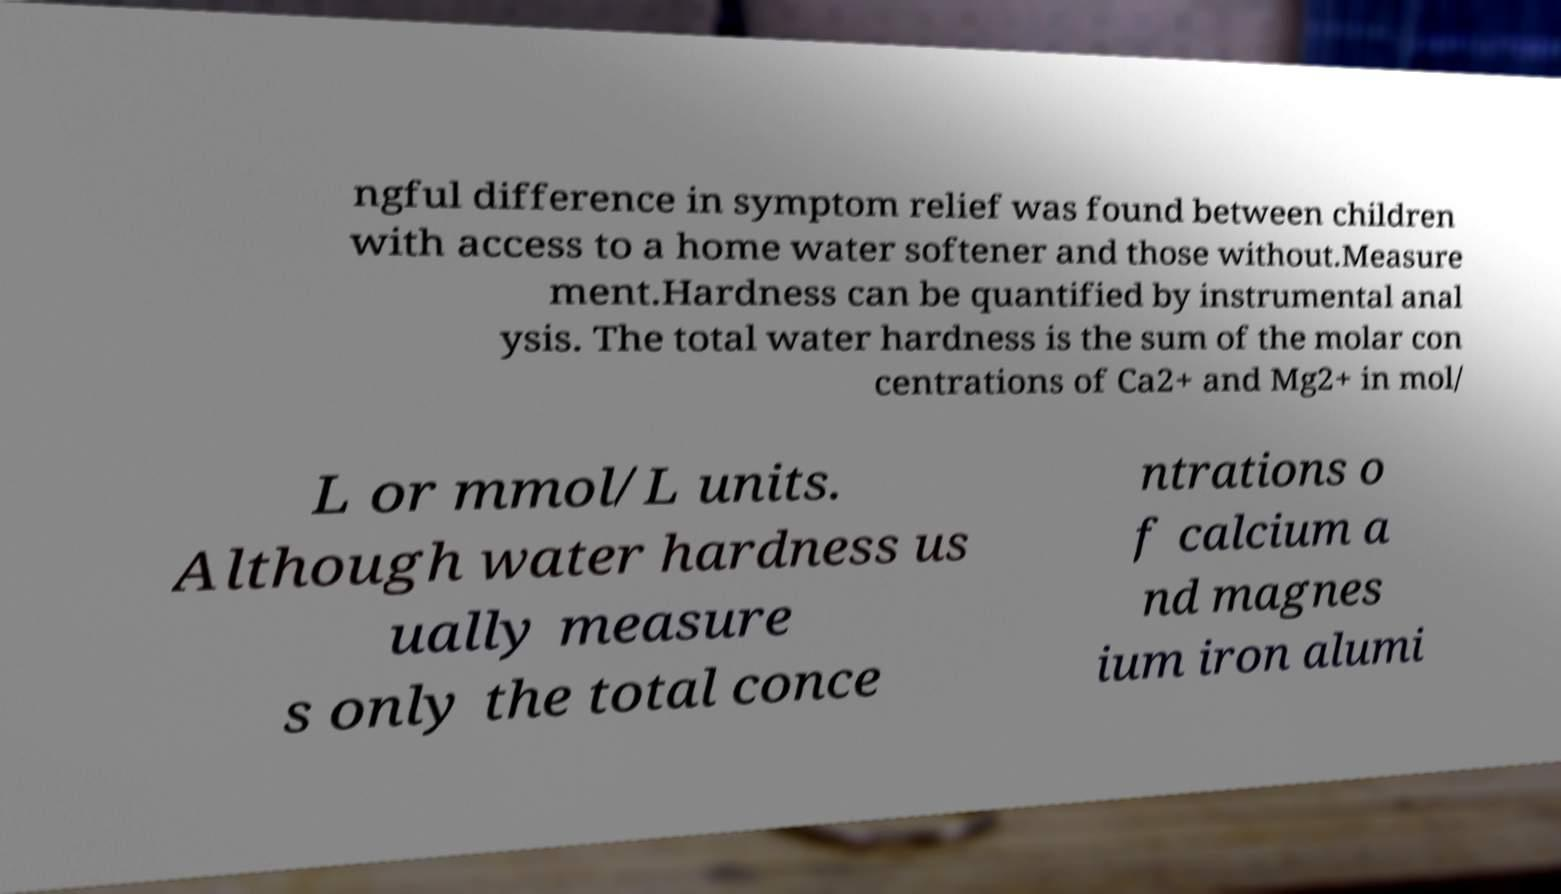I need the written content from this picture converted into text. Can you do that? ngful difference in symptom relief was found between children with access to a home water softener and those without.Measure ment.Hardness can be quantified by instrumental anal ysis. The total water hardness is the sum of the molar con centrations of Ca2+ and Mg2+ in mol/ L or mmol/L units. Although water hardness us ually measure s only the total conce ntrations o f calcium a nd magnes ium iron alumi 